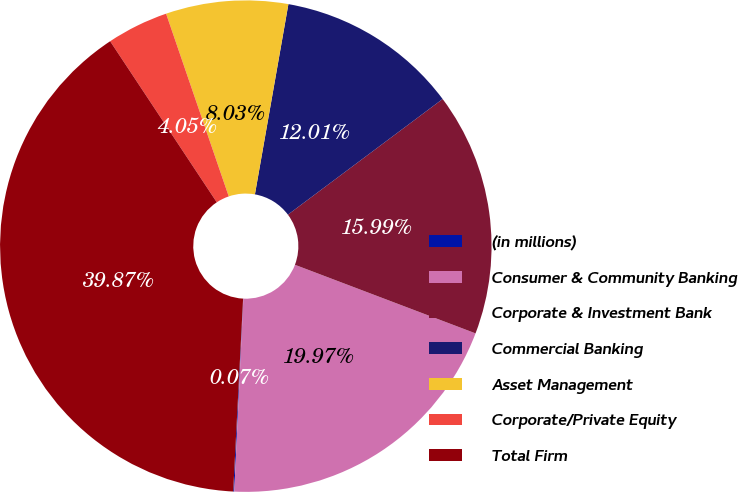Convert chart to OTSL. <chart><loc_0><loc_0><loc_500><loc_500><pie_chart><fcel>(in millions)<fcel>Consumer & Community Banking<fcel>Corporate & Investment Bank<fcel>Commercial Banking<fcel>Asset Management<fcel>Corporate/Private Equity<fcel>Total Firm<nl><fcel>0.07%<fcel>19.97%<fcel>15.99%<fcel>12.01%<fcel>8.03%<fcel>4.05%<fcel>39.87%<nl></chart> 